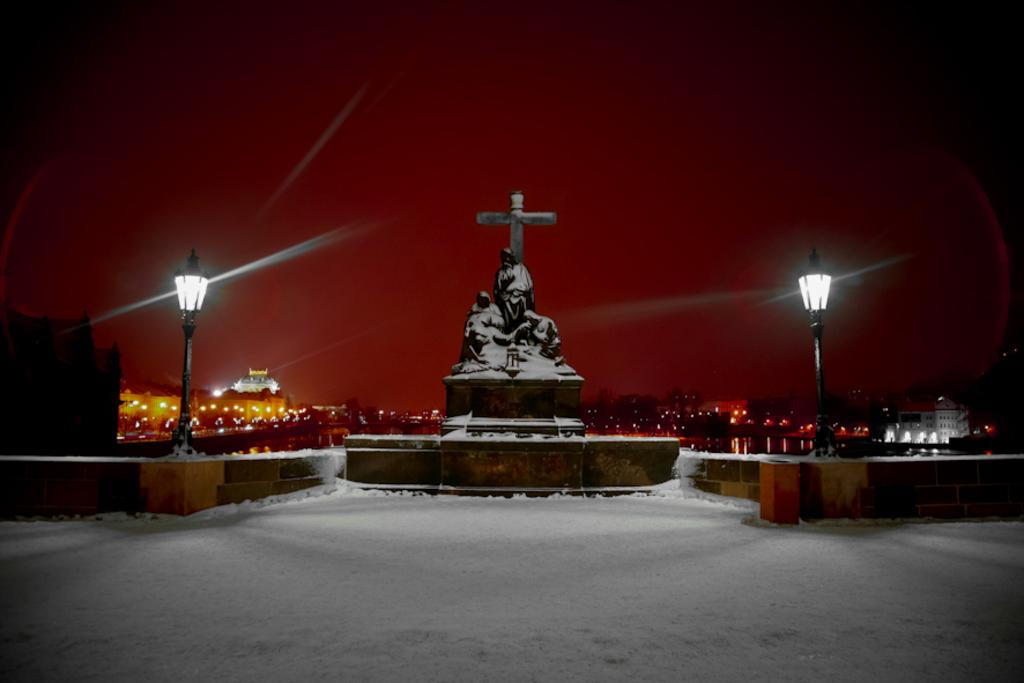What is the main subject in the center of the image? There is a statue in the center of the image. What can be seen on either side of the statue? There are street lights on both sides of the statue. What can be seen in the distance behind the statue? There are buildings and water visible in the background of the image. What is visible above the statue and buildings? The sky is visible in the background of the image. What type of mint is growing around the statue in the image? There is no mint visible in the image; it features a statue, street lights, buildings, water, and the sky. 